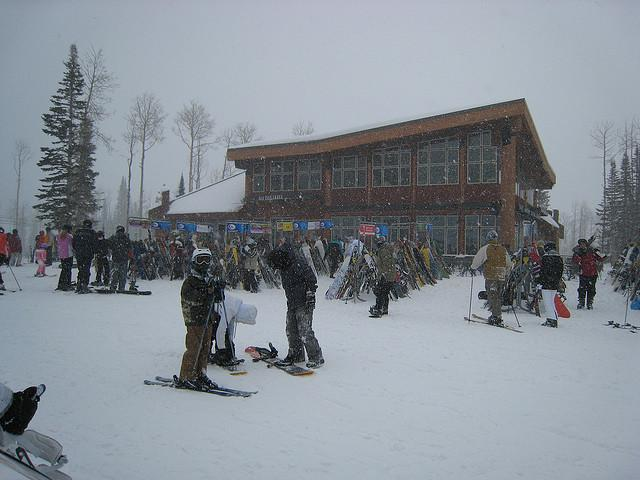Which weather phenomenon is likely to be most frustrating to people seen here at this place? Please explain your reasoning. heat wave. If it's hot, the snow that they need to ski will melt. 